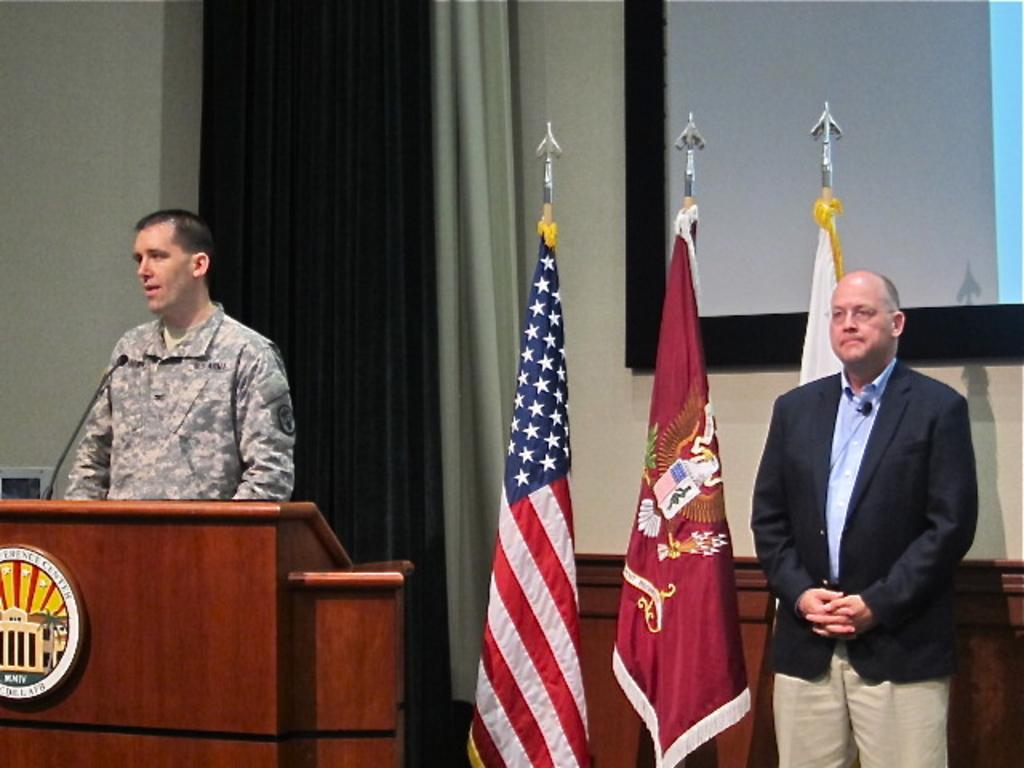What can be seen in the image involving people? There are people standing in the image. What object is present that might be used for speaking or addressing the crowd? A podium is present in the image. What device is used for amplifying sound in the image? A microphone (mic) is present in the image. What national symbols are visible in the image? There are flags in the image. What is used for displaying information or visuals in the image? There is a screen in the image. What type of pancake is being served on the podium in the image? There is no pancake present in the image; the podium is used for speaking or addressing the crowd. What kind of clouds can be seen in the image? There are no clouds visible in the image; it is an indoor setting. 